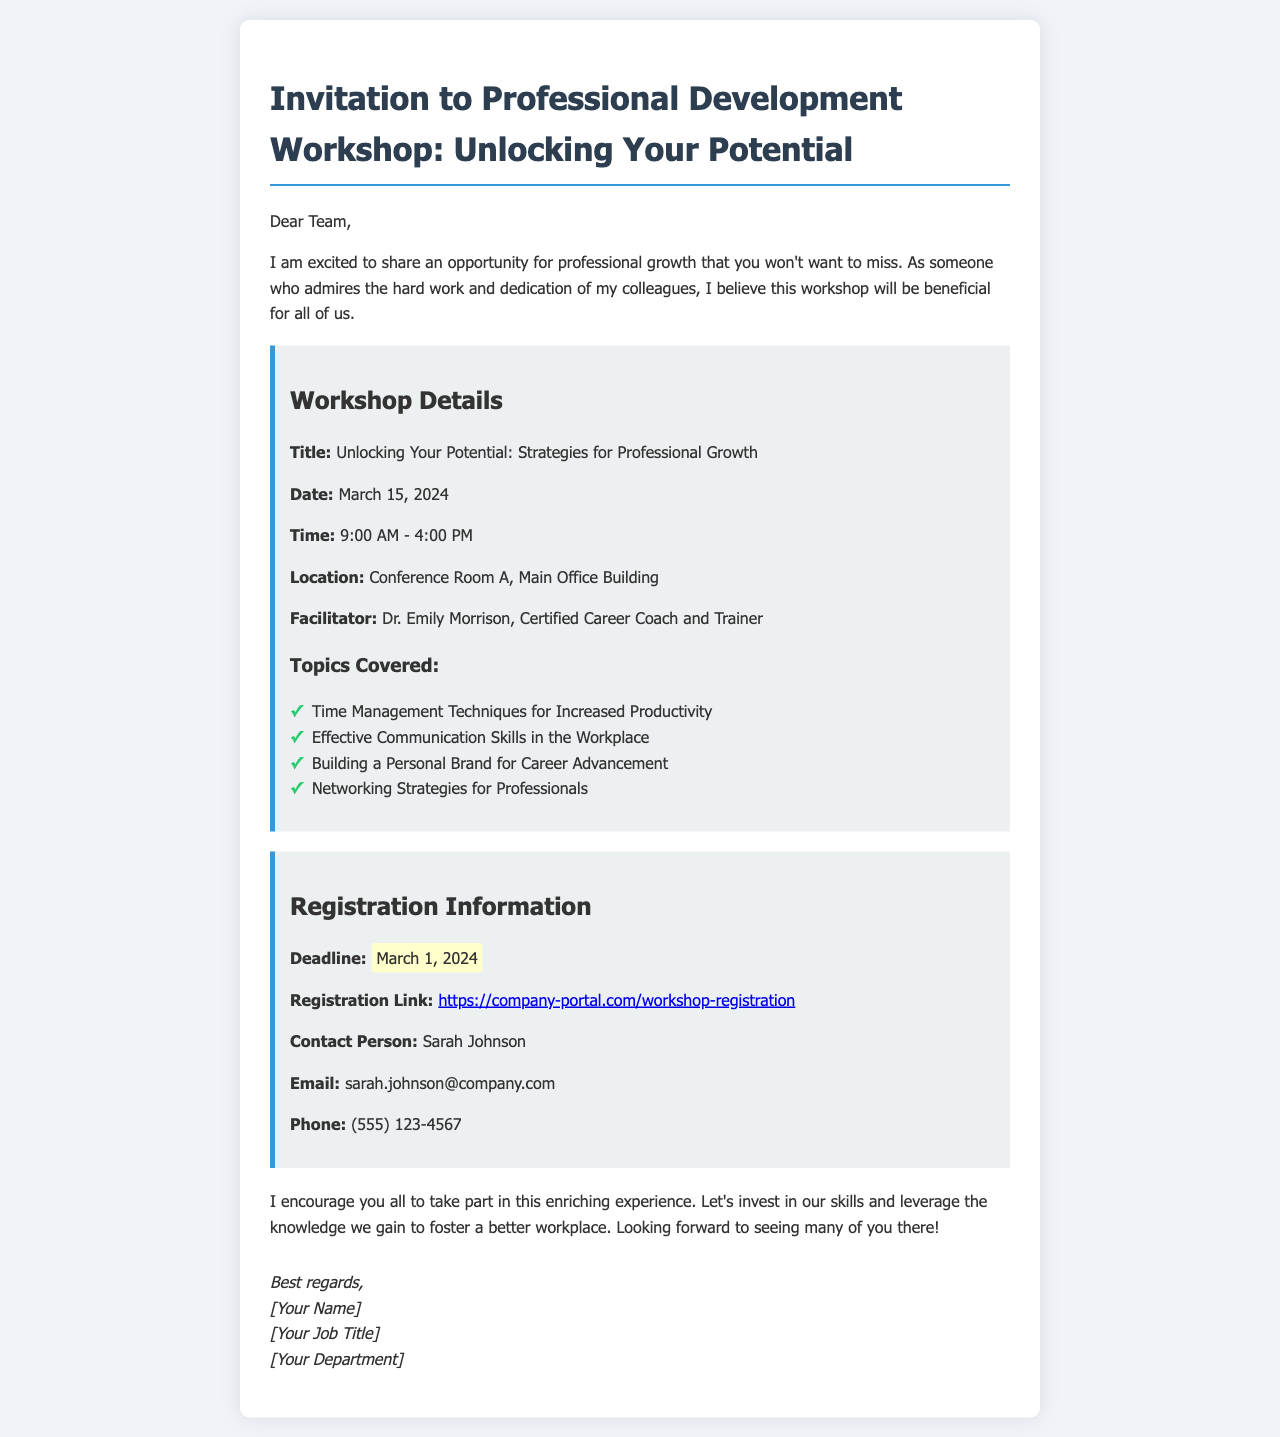What is the title of the workshop? The title of the workshop is provided in the document as "Unlocking Your Potential: Strategies for Professional Growth."
Answer: Unlocking Your Potential: Strategies for Professional Growth Who is the facilitator of the workshop? The document lists Dr. Emily Morrison as the facilitator of the workshop.
Answer: Dr. Emily Morrison What is the date of the workshop? The document specifies that the workshop will take place on March 15, 2024.
Answer: March 15, 2024 What is the registration deadline? The deadline for registration is highlighted in the document as March 1, 2024.
Answer: March 1, 2024 What topics will be covered in the workshop? The document lists several topics, including "Time Management Techniques for Increased Productivity."
Answer: Time Management Techniques for Increased Productivity How long is the workshop scheduled to run? The workshop is scheduled from 9:00 AM to 4:00 PM, which is a duration of seven hours.
Answer: 7 hours What is the location of the workshop? The document mentions that the location of the workshop is Conference Room A, Main Office Building.
Answer: Conference Room A, Main Office Building Who should be contacted for more information? The contact person for the workshop, as stated in the document, is Sarah Johnson.
Answer: Sarah Johnson What is the registration link provided in the document? The document includes a specific link for registration: https://company-portal.com/workshop-registration.
Answer: https://company-portal.com/workshop-registration 